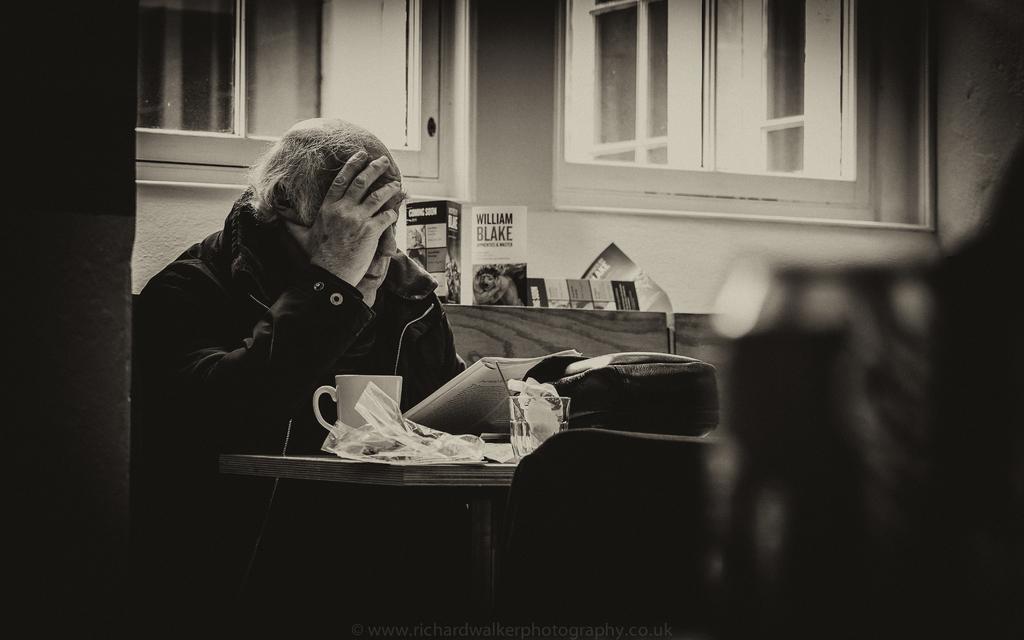In one or two sentences, can you explain what this image depicts? This is a black and white picture. I can see a person sitting, there is a book, glass, cup and some other objects on the table, and in the background there are windows and a wall. 